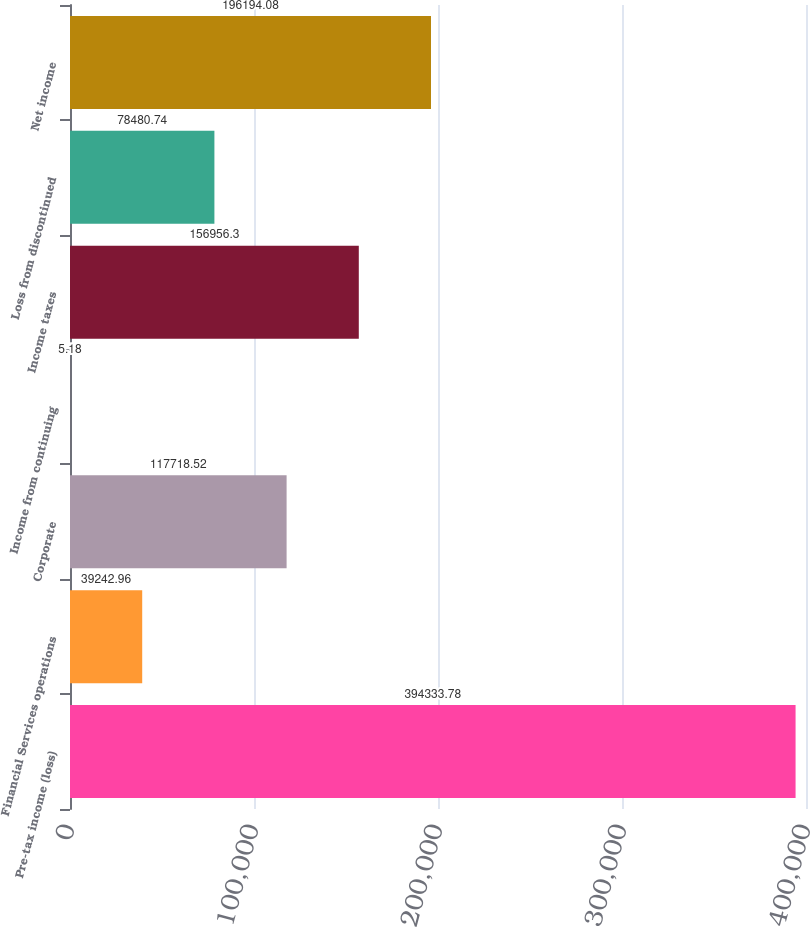Convert chart to OTSL. <chart><loc_0><loc_0><loc_500><loc_500><bar_chart><fcel>Pre-tax income (loss)<fcel>Financial Services operations<fcel>Corporate<fcel>Income from continuing<fcel>Income taxes<fcel>Loss from discontinued<fcel>Net income<nl><fcel>394334<fcel>39243<fcel>117719<fcel>5.18<fcel>156956<fcel>78480.7<fcel>196194<nl></chart> 